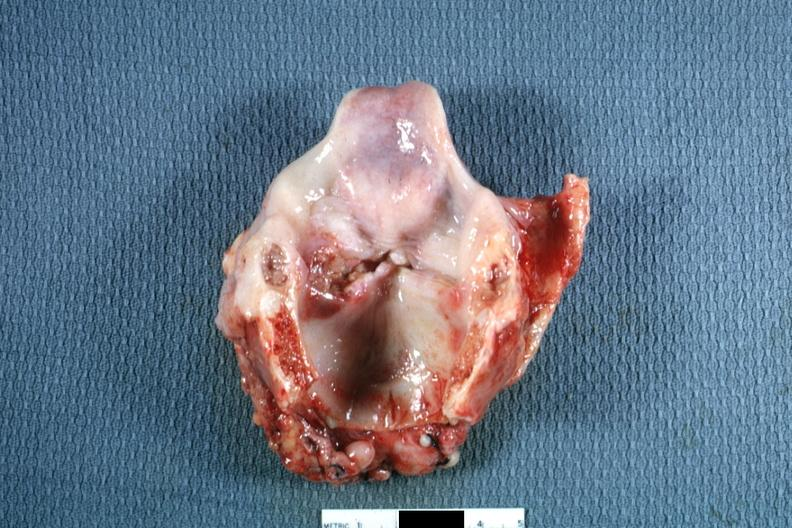s ulcerative lesion left true cord quite good?
Answer the question using a single word or phrase. Yes 